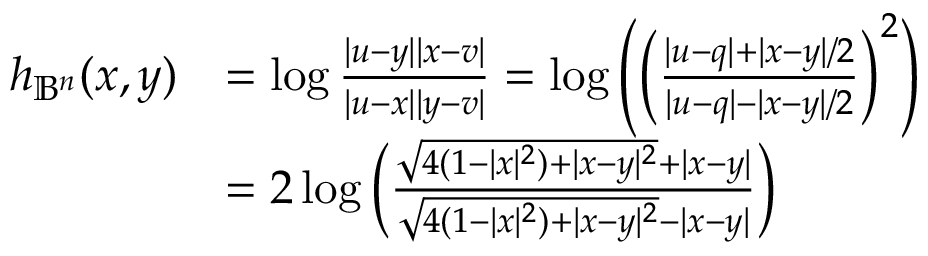Convert formula to latex. <formula><loc_0><loc_0><loc_500><loc_500>\begin{array} { r l } { h _ { \mathbb { B } ^ { n } } ( x , y ) } & { = \log \frac { | u - y | | x - v | } { | u - x | | y - v | } = \log \left ( \left ( \frac { | u - q | + | x - y | / 2 } { | u - q | - | x - y | / 2 } \right ) ^ { 2 } \right ) } \\ & { = 2 \log \left ( \frac { \sqrt { 4 ( 1 - | x | ^ { 2 } ) + | x - y | ^ { 2 } } + | x - y | } { \sqrt { 4 ( 1 - | x | ^ { 2 } ) + | x - y | ^ { 2 } } - | x - y | } \right ) } \end{array}</formula> 